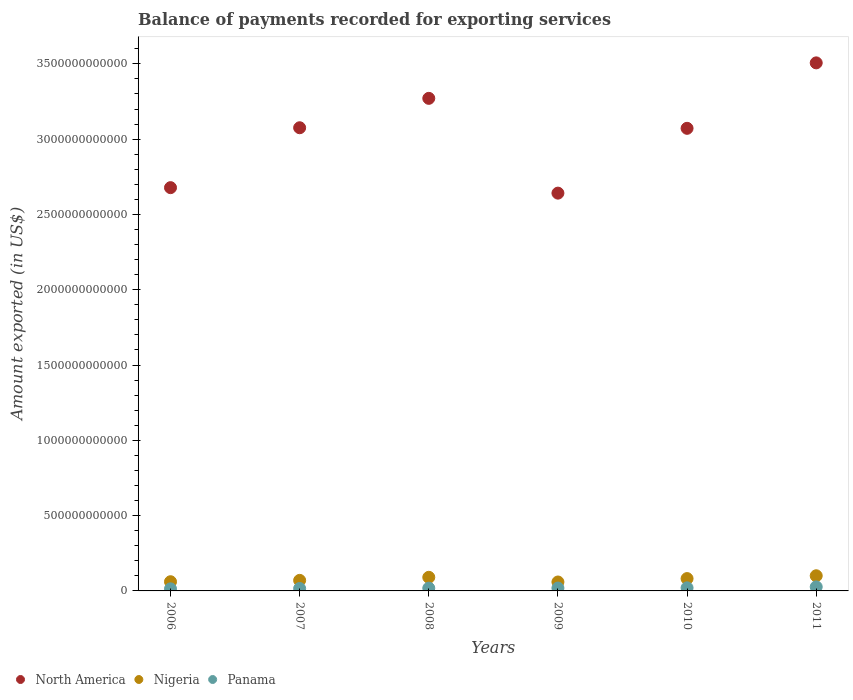Is the number of dotlines equal to the number of legend labels?
Your answer should be very brief. Yes. What is the amount exported in Nigeria in 2011?
Give a very brief answer. 1.01e+11. Across all years, what is the maximum amount exported in Nigeria?
Provide a short and direct response. 1.01e+11. Across all years, what is the minimum amount exported in Nigeria?
Offer a very short reply. 5.93e+1. In which year was the amount exported in Panama maximum?
Your response must be concise. 2011. What is the total amount exported in Panama in the graph?
Offer a terse response. 1.15e+11. What is the difference between the amount exported in Panama in 2006 and that in 2007?
Give a very brief answer. -2.28e+09. What is the difference between the amount exported in Panama in 2011 and the amount exported in North America in 2007?
Provide a short and direct response. -3.05e+12. What is the average amount exported in North America per year?
Your response must be concise. 3.04e+12. In the year 2006, what is the difference between the amount exported in Panama and amount exported in Nigeria?
Offer a terse response. -4.73e+1. In how many years, is the amount exported in Nigeria greater than 2500000000000 US$?
Your answer should be very brief. 0. What is the ratio of the amount exported in Panama in 2006 to that in 2011?
Ensure brevity in your answer.  0.51. Is the amount exported in Nigeria in 2008 less than that in 2010?
Offer a very short reply. No. What is the difference between the highest and the second highest amount exported in Panama?
Give a very brief answer. 6.36e+09. What is the difference between the highest and the lowest amount exported in Panama?
Give a very brief answer. 1.30e+1. Does the amount exported in Nigeria monotonically increase over the years?
Make the answer very short. No. How many years are there in the graph?
Keep it short and to the point. 6. What is the difference between two consecutive major ticks on the Y-axis?
Give a very brief answer. 5.00e+11. Are the values on the major ticks of Y-axis written in scientific E-notation?
Give a very brief answer. No. Does the graph contain any zero values?
Offer a very short reply. No. How are the legend labels stacked?
Make the answer very short. Horizontal. What is the title of the graph?
Make the answer very short. Balance of payments recorded for exporting services. What is the label or title of the Y-axis?
Provide a short and direct response. Amount exported (in US$). What is the Amount exported (in US$) of North America in 2006?
Keep it short and to the point. 2.68e+12. What is the Amount exported (in US$) of Nigeria in 2006?
Offer a terse response. 6.11e+1. What is the Amount exported (in US$) in Panama in 2006?
Provide a succinct answer. 1.38e+1. What is the Amount exported (in US$) in North America in 2007?
Your answer should be very brief. 3.08e+12. What is the Amount exported (in US$) in Nigeria in 2007?
Offer a very short reply. 7.00e+1. What is the Amount exported (in US$) in Panama in 2007?
Make the answer very short. 1.61e+1. What is the Amount exported (in US$) of North America in 2008?
Offer a terse response. 3.27e+12. What is the Amount exported (in US$) of Nigeria in 2008?
Ensure brevity in your answer.  9.04e+1. What is the Amount exported (in US$) of Panama in 2008?
Make the answer very short. 1.83e+1. What is the Amount exported (in US$) of North America in 2009?
Your answer should be compact. 2.64e+12. What is the Amount exported (in US$) of Nigeria in 2009?
Offer a very short reply. 5.93e+1. What is the Amount exported (in US$) in Panama in 2009?
Give a very brief answer. 1.90e+1. What is the Amount exported (in US$) of North America in 2010?
Your response must be concise. 3.07e+12. What is the Amount exported (in US$) of Nigeria in 2010?
Make the answer very short. 8.20e+1. What is the Amount exported (in US$) in Panama in 2010?
Offer a very short reply. 2.05e+1. What is the Amount exported (in US$) of North America in 2011?
Keep it short and to the point. 3.51e+12. What is the Amount exported (in US$) in Nigeria in 2011?
Offer a terse response. 1.01e+11. What is the Amount exported (in US$) in Panama in 2011?
Keep it short and to the point. 2.69e+1. Across all years, what is the maximum Amount exported (in US$) of North America?
Your answer should be very brief. 3.51e+12. Across all years, what is the maximum Amount exported (in US$) in Nigeria?
Your answer should be very brief. 1.01e+11. Across all years, what is the maximum Amount exported (in US$) in Panama?
Your answer should be very brief. 2.69e+1. Across all years, what is the minimum Amount exported (in US$) in North America?
Make the answer very short. 2.64e+12. Across all years, what is the minimum Amount exported (in US$) of Nigeria?
Ensure brevity in your answer.  5.93e+1. Across all years, what is the minimum Amount exported (in US$) of Panama?
Provide a short and direct response. 1.38e+1. What is the total Amount exported (in US$) in North America in the graph?
Your response must be concise. 1.82e+13. What is the total Amount exported (in US$) in Nigeria in the graph?
Give a very brief answer. 4.63e+11. What is the total Amount exported (in US$) in Panama in the graph?
Keep it short and to the point. 1.15e+11. What is the difference between the Amount exported (in US$) in North America in 2006 and that in 2007?
Make the answer very short. -3.98e+11. What is the difference between the Amount exported (in US$) in Nigeria in 2006 and that in 2007?
Offer a very short reply. -8.94e+09. What is the difference between the Amount exported (in US$) in Panama in 2006 and that in 2007?
Keep it short and to the point. -2.28e+09. What is the difference between the Amount exported (in US$) of North America in 2006 and that in 2008?
Your answer should be very brief. -5.93e+11. What is the difference between the Amount exported (in US$) in Nigeria in 2006 and that in 2008?
Your answer should be very brief. -2.93e+1. What is the difference between the Amount exported (in US$) in Panama in 2006 and that in 2008?
Keep it short and to the point. -4.47e+09. What is the difference between the Amount exported (in US$) in North America in 2006 and that in 2009?
Provide a short and direct response. 3.64e+1. What is the difference between the Amount exported (in US$) in Nigeria in 2006 and that in 2009?
Offer a terse response. 1.79e+09. What is the difference between the Amount exported (in US$) of Panama in 2006 and that in 2009?
Keep it short and to the point. -5.18e+09. What is the difference between the Amount exported (in US$) in North America in 2006 and that in 2010?
Offer a very short reply. -3.94e+11. What is the difference between the Amount exported (in US$) in Nigeria in 2006 and that in 2010?
Ensure brevity in your answer.  -2.09e+1. What is the difference between the Amount exported (in US$) of Panama in 2006 and that in 2010?
Provide a succinct answer. -6.69e+09. What is the difference between the Amount exported (in US$) of North America in 2006 and that in 2011?
Ensure brevity in your answer.  -8.29e+11. What is the difference between the Amount exported (in US$) in Nigeria in 2006 and that in 2011?
Provide a short and direct response. -3.95e+1. What is the difference between the Amount exported (in US$) in Panama in 2006 and that in 2011?
Your response must be concise. -1.30e+1. What is the difference between the Amount exported (in US$) in North America in 2007 and that in 2008?
Your answer should be very brief. -1.95e+11. What is the difference between the Amount exported (in US$) in Nigeria in 2007 and that in 2008?
Offer a terse response. -2.03e+1. What is the difference between the Amount exported (in US$) in Panama in 2007 and that in 2008?
Your answer should be compact. -2.19e+09. What is the difference between the Amount exported (in US$) of North America in 2007 and that in 2009?
Offer a terse response. 4.34e+11. What is the difference between the Amount exported (in US$) in Nigeria in 2007 and that in 2009?
Make the answer very short. 1.07e+1. What is the difference between the Amount exported (in US$) of Panama in 2007 and that in 2009?
Give a very brief answer. -2.90e+09. What is the difference between the Amount exported (in US$) in North America in 2007 and that in 2010?
Your response must be concise. 3.78e+09. What is the difference between the Amount exported (in US$) in Nigeria in 2007 and that in 2010?
Provide a short and direct response. -1.19e+1. What is the difference between the Amount exported (in US$) in Panama in 2007 and that in 2010?
Give a very brief answer. -4.41e+09. What is the difference between the Amount exported (in US$) of North America in 2007 and that in 2011?
Your answer should be very brief. -4.31e+11. What is the difference between the Amount exported (in US$) in Nigeria in 2007 and that in 2011?
Your response must be concise. -3.06e+1. What is the difference between the Amount exported (in US$) in Panama in 2007 and that in 2011?
Ensure brevity in your answer.  -1.08e+1. What is the difference between the Amount exported (in US$) of North America in 2008 and that in 2009?
Your answer should be very brief. 6.29e+11. What is the difference between the Amount exported (in US$) in Nigeria in 2008 and that in 2009?
Your answer should be compact. 3.11e+1. What is the difference between the Amount exported (in US$) of Panama in 2008 and that in 2009?
Your response must be concise. -7.11e+08. What is the difference between the Amount exported (in US$) in North America in 2008 and that in 2010?
Your response must be concise. 1.99e+11. What is the difference between the Amount exported (in US$) of Nigeria in 2008 and that in 2010?
Offer a terse response. 8.41e+09. What is the difference between the Amount exported (in US$) in Panama in 2008 and that in 2010?
Make the answer very short. -2.22e+09. What is the difference between the Amount exported (in US$) of North America in 2008 and that in 2011?
Offer a terse response. -2.36e+11. What is the difference between the Amount exported (in US$) in Nigeria in 2008 and that in 2011?
Give a very brief answer. -1.03e+1. What is the difference between the Amount exported (in US$) in Panama in 2008 and that in 2011?
Offer a very short reply. -8.58e+09. What is the difference between the Amount exported (in US$) of North America in 2009 and that in 2010?
Give a very brief answer. -4.30e+11. What is the difference between the Amount exported (in US$) in Nigeria in 2009 and that in 2010?
Your answer should be very brief. -2.27e+1. What is the difference between the Amount exported (in US$) of Panama in 2009 and that in 2010?
Keep it short and to the point. -1.51e+09. What is the difference between the Amount exported (in US$) in North America in 2009 and that in 2011?
Offer a terse response. -8.65e+11. What is the difference between the Amount exported (in US$) of Nigeria in 2009 and that in 2011?
Provide a short and direct response. -4.13e+1. What is the difference between the Amount exported (in US$) of Panama in 2009 and that in 2011?
Keep it short and to the point. -7.87e+09. What is the difference between the Amount exported (in US$) in North America in 2010 and that in 2011?
Ensure brevity in your answer.  -4.35e+11. What is the difference between the Amount exported (in US$) in Nigeria in 2010 and that in 2011?
Ensure brevity in your answer.  -1.87e+1. What is the difference between the Amount exported (in US$) of Panama in 2010 and that in 2011?
Your answer should be very brief. -6.36e+09. What is the difference between the Amount exported (in US$) in North America in 2006 and the Amount exported (in US$) in Nigeria in 2007?
Your answer should be compact. 2.61e+12. What is the difference between the Amount exported (in US$) of North America in 2006 and the Amount exported (in US$) of Panama in 2007?
Provide a short and direct response. 2.66e+12. What is the difference between the Amount exported (in US$) of Nigeria in 2006 and the Amount exported (in US$) of Panama in 2007?
Make the answer very short. 4.50e+1. What is the difference between the Amount exported (in US$) of North America in 2006 and the Amount exported (in US$) of Nigeria in 2008?
Your answer should be very brief. 2.59e+12. What is the difference between the Amount exported (in US$) in North America in 2006 and the Amount exported (in US$) in Panama in 2008?
Your response must be concise. 2.66e+12. What is the difference between the Amount exported (in US$) of Nigeria in 2006 and the Amount exported (in US$) of Panama in 2008?
Your response must be concise. 4.28e+1. What is the difference between the Amount exported (in US$) in North America in 2006 and the Amount exported (in US$) in Nigeria in 2009?
Make the answer very short. 2.62e+12. What is the difference between the Amount exported (in US$) of North America in 2006 and the Amount exported (in US$) of Panama in 2009?
Your response must be concise. 2.66e+12. What is the difference between the Amount exported (in US$) of Nigeria in 2006 and the Amount exported (in US$) of Panama in 2009?
Ensure brevity in your answer.  4.21e+1. What is the difference between the Amount exported (in US$) of North America in 2006 and the Amount exported (in US$) of Nigeria in 2010?
Offer a terse response. 2.60e+12. What is the difference between the Amount exported (in US$) in North America in 2006 and the Amount exported (in US$) in Panama in 2010?
Offer a terse response. 2.66e+12. What is the difference between the Amount exported (in US$) of Nigeria in 2006 and the Amount exported (in US$) of Panama in 2010?
Offer a terse response. 4.06e+1. What is the difference between the Amount exported (in US$) of North America in 2006 and the Amount exported (in US$) of Nigeria in 2011?
Your answer should be very brief. 2.58e+12. What is the difference between the Amount exported (in US$) in North America in 2006 and the Amount exported (in US$) in Panama in 2011?
Provide a succinct answer. 2.65e+12. What is the difference between the Amount exported (in US$) of Nigeria in 2006 and the Amount exported (in US$) of Panama in 2011?
Give a very brief answer. 3.42e+1. What is the difference between the Amount exported (in US$) of North America in 2007 and the Amount exported (in US$) of Nigeria in 2008?
Make the answer very short. 2.99e+12. What is the difference between the Amount exported (in US$) of North America in 2007 and the Amount exported (in US$) of Panama in 2008?
Make the answer very short. 3.06e+12. What is the difference between the Amount exported (in US$) of Nigeria in 2007 and the Amount exported (in US$) of Panama in 2008?
Your response must be concise. 5.17e+1. What is the difference between the Amount exported (in US$) in North America in 2007 and the Amount exported (in US$) in Nigeria in 2009?
Provide a succinct answer. 3.02e+12. What is the difference between the Amount exported (in US$) of North America in 2007 and the Amount exported (in US$) of Panama in 2009?
Keep it short and to the point. 3.06e+12. What is the difference between the Amount exported (in US$) in Nigeria in 2007 and the Amount exported (in US$) in Panama in 2009?
Give a very brief answer. 5.10e+1. What is the difference between the Amount exported (in US$) in North America in 2007 and the Amount exported (in US$) in Nigeria in 2010?
Make the answer very short. 2.99e+12. What is the difference between the Amount exported (in US$) of North America in 2007 and the Amount exported (in US$) of Panama in 2010?
Give a very brief answer. 3.06e+12. What is the difference between the Amount exported (in US$) of Nigeria in 2007 and the Amount exported (in US$) of Panama in 2010?
Offer a terse response. 4.95e+1. What is the difference between the Amount exported (in US$) in North America in 2007 and the Amount exported (in US$) in Nigeria in 2011?
Your answer should be compact. 2.98e+12. What is the difference between the Amount exported (in US$) of North America in 2007 and the Amount exported (in US$) of Panama in 2011?
Your answer should be very brief. 3.05e+12. What is the difference between the Amount exported (in US$) of Nigeria in 2007 and the Amount exported (in US$) of Panama in 2011?
Ensure brevity in your answer.  4.32e+1. What is the difference between the Amount exported (in US$) in North America in 2008 and the Amount exported (in US$) in Nigeria in 2009?
Provide a succinct answer. 3.21e+12. What is the difference between the Amount exported (in US$) in North America in 2008 and the Amount exported (in US$) in Panama in 2009?
Make the answer very short. 3.25e+12. What is the difference between the Amount exported (in US$) of Nigeria in 2008 and the Amount exported (in US$) of Panama in 2009?
Provide a short and direct response. 7.14e+1. What is the difference between the Amount exported (in US$) of North America in 2008 and the Amount exported (in US$) of Nigeria in 2010?
Your answer should be compact. 3.19e+12. What is the difference between the Amount exported (in US$) of North America in 2008 and the Amount exported (in US$) of Panama in 2010?
Make the answer very short. 3.25e+12. What is the difference between the Amount exported (in US$) in Nigeria in 2008 and the Amount exported (in US$) in Panama in 2010?
Give a very brief answer. 6.99e+1. What is the difference between the Amount exported (in US$) of North America in 2008 and the Amount exported (in US$) of Nigeria in 2011?
Make the answer very short. 3.17e+12. What is the difference between the Amount exported (in US$) in North America in 2008 and the Amount exported (in US$) in Panama in 2011?
Offer a very short reply. 3.24e+12. What is the difference between the Amount exported (in US$) in Nigeria in 2008 and the Amount exported (in US$) in Panama in 2011?
Provide a short and direct response. 6.35e+1. What is the difference between the Amount exported (in US$) in North America in 2009 and the Amount exported (in US$) in Nigeria in 2010?
Offer a very short reply. 2.56e+12. What is the difference between the Amount exported (in US$) in North America in 2009 and the Amount exported (in US$) in Panama in 2010?
Give a very brief answer. 2.62e+12. What is the difference between the Amount exported (in US$) of Nigeria in 2009 and the Amount exported (in US$) of Panama in 2010?
Offer a terse response. 3.88e+1. What is the difference between the Amount exported (in US$) of North America in 2009 and the Amount exported (in US$) of Nigeria in 2011?
Provide a succinct answer. 2.54e+12. What is the difference between the Amount exported (in US$) in North America in 2009 and the Amount exported (in US$) in Panama in 2011?
Keep it short and to the point. 2.61e+12. What is the difference between the Amount exported (in US$) of Nigeria in 2009 and the Amount exported (in US$) of Panama in 2011?
Offer a very short reply. 3.24e+1. What is the difference between the Amount exported (in US$) of North America in 2010 and the Amount exported (in US$) of Nigeria in 2011?
Your response must be concise. 2.97e+12. What is the difference between the Amount exported (in US$) in North America in 2010 and the Amount exported (in US$) in Panama in 2011?
Your answer should be very brief. 3.05e+12. What is the difference between the Amount exported (in US$) in Nigeria in 2010 and the Amount exported (in US$) in Panama in 2011?
Your response must be concise. 5.51e+1. What is the average Amount exported (in US$) of North America per year?
Your answer should be compact. 3.04e+12. What is the average Amount exported (in US$) of Nigeria per year?
Your response must be concise. 7.72e+1. What is the average Amount exported (in US$) in Panama per year?
Offer a very short reply. 1.91e+1. In the year 2006, what is the difference between the Amount exported (in US$) of North America and Amount exported (in US$) of Nigeria?
Your answer should be compact. 2.62e+12. In the year 2006, what is the difference between the Amount exported (in US$) of North America and Amount exported (in US$) of Panama?
Ensure brevity in your answer.  2.66e+12. In the year 2006, what is the difference between the Amount exported (in US$) of Nigeria and Amount exported (in US$) of Panama?
Keep it short and to the point. 4.73e+1. In the year 2007, what is the difference between the Amount exported (in US$) of North America and Amount exported (in US$) of Nigeria?
Your response must be concise. 3.01e+12. In the year 2007, what is the difference between the Amount exported (in US$) of North America and Amount exported (in US$) of Panama?
Keep it short and to the point. 3.06e+12. In the year 2007, what is the difference between the Amount exported (in US$) in Nigeria and Amount exported (in US$) in Panama?
Offer a terse response. 5.39e+1. In the year 2008, what is the difference between the Amount exported (in US$) in North America and Amount exported (in US$) in Nigeria?
Keep it short and to the point. 3.18e+12. In the year 2008, what is the difference between the Amount exported (in US$) in North America and Amount exported (in US$) in Panama?
Keep it short and to the point. 3.25e+12. In the year 2008, what is the difference between the Amount exported (in US$) of Nigeria and Amount exported (in US$) of Panama?
Make the answer very short. 7.21e+1. In the year 2009, what is the difference between the Amount exported (in US$) in North America and Amount exported (in US$) in Nigeria?
Provide a succinct answer. 2.58e+12. In the year 2009, what is the difference between the Amount exported (in US$) in North America and Amount exported (in US$) in Panama?
Offer a very short reply. 2.62e+12. In the year 2009, what is the difference between the Amount exported (in US$) of Nigeria and Amount exported (in US$) of Panama?
Provide a short and direct response. 4.03e+1. In the year 2010, what is the difference between the Amount exported (in US$) in North America and Amount exported (in US$) in Nigeria?
Your answer should be very brief. 2.99e+12. In the year 2010, what is the difference between the Amount exported (in US$) of North America and Amount exported (in US$) of Panama?
Provide a short and direct response. 3.05e+12. In the year 2010, what is the difference between the Amount exported (in US$) of Nigeria and Amount exported (in US$) of Panama?
Your response must be concise. 6.14e+1. In the year 2011, what is the difference between the Amount exported (in US$) in North America and Amount exported (in US$) in Nigeria?
Your response must be concise. 3.41e+12. In the year 2011, what is the difference between the Amount exported (in US$) in North America and Amount exported (in US$) in Panama?
Keep it short and to the point. 3.48e+12. In the year 2011, what is the difference between the Amount exported (in US$) of Nigeria and Amount exported (in US$) of Panama?
Provide a short and direct response. 7.38e+1. What is the ratio of the Amount exported (in US$) of North America in 2006 to that in 2007?
Provide a short and direct response. 0.87. What is the ratio of the Amount exported (in US$) of Nigeria in 2006 to that in 2007?
Provide a succinct answer. 0.87. What is the ratio of the Amount exported (in US$) of Panama in 2006 to that in 2007?
Ensure brevity in your answer.  0.86. What is the ratio of the Amount exported (in US$) in North America in 2006 to that in 2008?
Your answer should be compact. 0.82. What is the ratio of the Amount exported (in US$) of Nigeria in 2006 to that in 2008?
Ensure brevity in your answer.  0.68. What is the ratio of the Amount exported (in US$) in Panama in 2006 to that in 2008?
Provide a short and direct response. 0.76. What is the ratio of the Amount exported (in US$) in North America in 2006 to that in 2009?
Provide a succinct answer. 1.01. What is the ratio of the Amount exported (in US$) in Nigeria in 2006 to that in 2009?
Offer a terse response. 1.03. What is the ratio of the Amount exported (in US$) in Panama in 2006 to that in 2009?
Provide a short and direct response. 0.73. What is the ratio of the Amount exported (in US$) in North America in 2006 to that in 2010?
Keep it short and to the point. 0.87. What is the ratio of the Amount exported (in US$) in Nigeria in 2006 to that in 2010?
Provide a succinct answer. 0.75. What is the ratio of the Amount exported (in US$) in Panama in 2006 to that in 2010?
Provide a short and direct response. 0.67. What is the ratio of the Amount exported (in US$) of North America in 2006 to that in 2011?
Give a very brief answer. 0.76. What is the ratio of the Amount exported (in US$) in Nigeria in 2006 to that in 2011?
Offer a very short reply. 0.61. What is the ratio of the Amount exported (in US$) in Panama in 2006 to that in 2011?
Give a very brief answer. 0.51. What is the ratio of the Amount exported (in US$) of North America in 2007 to that in 2008?
Offer a terse response. 0.94. What is the ratio of the Amount exported (in US$) of Nigeria in 2007 to that in 2008?
Ensure brevity in your answer.  0.78. What is the ratio of the Amount exported (in US$) of Panama in 2007 to that in 2008?
Make the answer very short. 0.88. What is the ratio of the Amount exported (in US$) of North America in 2007 to that in 2009?
Provide a succinct answer. 1.16. What is the ratio of the Amount exported (in US$) in Nigeria in 2007 to that in 2009?
Keep it short and to the point. 1.18. What is the ratio of the Amount exported (in US$) in Panama in 2007 to that in 2009?
Keep it short and to the point. 0.85. What is the ratio of the Amount exported (in US$) in North America in 2007 to that in 2010?
Offer a terse response. 1. What is the ratio of the Amount exported (in US$) in Nigeria in 2007 to that in 2010?
Your answer should be very brief. 0.85. What is the ratio of the Amount exported (in US$) of Panama in 2007 to that in 2010?
Offer a terse response. 0.79. What is the ratio of the Amount exported (in US$) of North America in 2007 to that in 2011?
Offer a very short reply. 0.88. What is the ratio of the Amount exported (in US$) in Nigeria in 2007 to that in 2011?
Ensure brevity in your answer.  0.7. What is the ratio of the Amount exported (in US$) of Panama in 2007 to that in 2011?
Give a very brief answer. 0.6. What is the ratio of the Amount exported (in US$) in North America in 2008 to that in 2009?
Offer a very short reply. 1.24. What is the ratio of the Amount exported (in US$) in Nigeria in 2008 to that in 2009?
Your response must be concise. 1.52. What is the ratio of the Amount exported (in US$) in Panama in 2008 to that in 2009?
Ensure brevity in your answer.  0.96. What is the ratio of the Amount exported (in US$) in North America in 2008 to that in 2010?
Give a very brief answer. 1.06. What is the ratio of the Amount exported (in US$) of Nigeria in 2008 to that in 2010?
Provide a succinct answer. 1.1. What is the ratio of the Amount exported (in US$) of Panama in 2008 to that in 2010?
Provide a succinct answer. 0.89. What is the ratio of the Amount exported (in US$) in North America in 2008 to that in 2011?
Your answer should be compact. 0.93. What is the ratio of the Amount exported (in US$) of Nigeria in 2008 to that in 2011?
Provide a short and direct response. 0.9. What is the ratio of the Amount exported (in US$) of Panama in 2008 to that in 2011?
Offer a very short reply. 0.68. What is the ratio of the Amount exported (in US$) of North America in 2009 to that in 2010?
Make the answer very short. 0.86. What is the ratio of the Amount exported (in US$) in Nigeria in 2009 to that in 2010?
Your answer should be very brief. 0.72. What is the ratio of the Amount exported (in US$) of Panama in 2009 to that in 2010?
Keep it short and to the point. 0.93. What is the ratio of the Amount exported (in US$) of North America in 2009 to that in 2011?
Your answer should be compact. 0.75. What is the ratio of the Amount exported (in US$) of Nigeria in 2009 to that in 2011?
Your response must be concise. 0.59. What is the ratio of the Amount exported (in US$) of Panama in 2009 to that in 2011?
Offer a terse response. 0.71. What is the ratio of the Amount exported (in US$) in North America in 2010 to that in 2011?
Your answer should be compact. 0.88. What is the ratio of the Amount exported (in US$) of Nigeria in 2010 to that in 2011?
Offer a terse response. 0.81. What is the ratio of the Amount exported (in US$) in Panama in 2010 to that in 2011?
Offer a very short reply. 0.76. What is the difference between the highest and the second highest Amount exported (in US$) in North America?
Your answer should be very brief. 2.36e+11. What is the difference between the highest and the second highest Amount exported (in US$) in Nigeria?
Offer a terse response. 1.03e+1. What is the difference between the highest and the second highest Amount exported (in US$) in Panama?
Offer a very short reply. 6.36e+09. What is the difference between the highest and the lowest Amount exported (in US$) of North America?
Provide a succinct answer. 8.65e+11. What is the difference between the highest and the lowest Amount exported (in US$) in Nigeria?
Ensure brevity in your answer.  4.13e+1. What is the difference between the highest and the lowest Amount exported (in US$) of Panama?
Offer a terse response. 1.30e+1. 